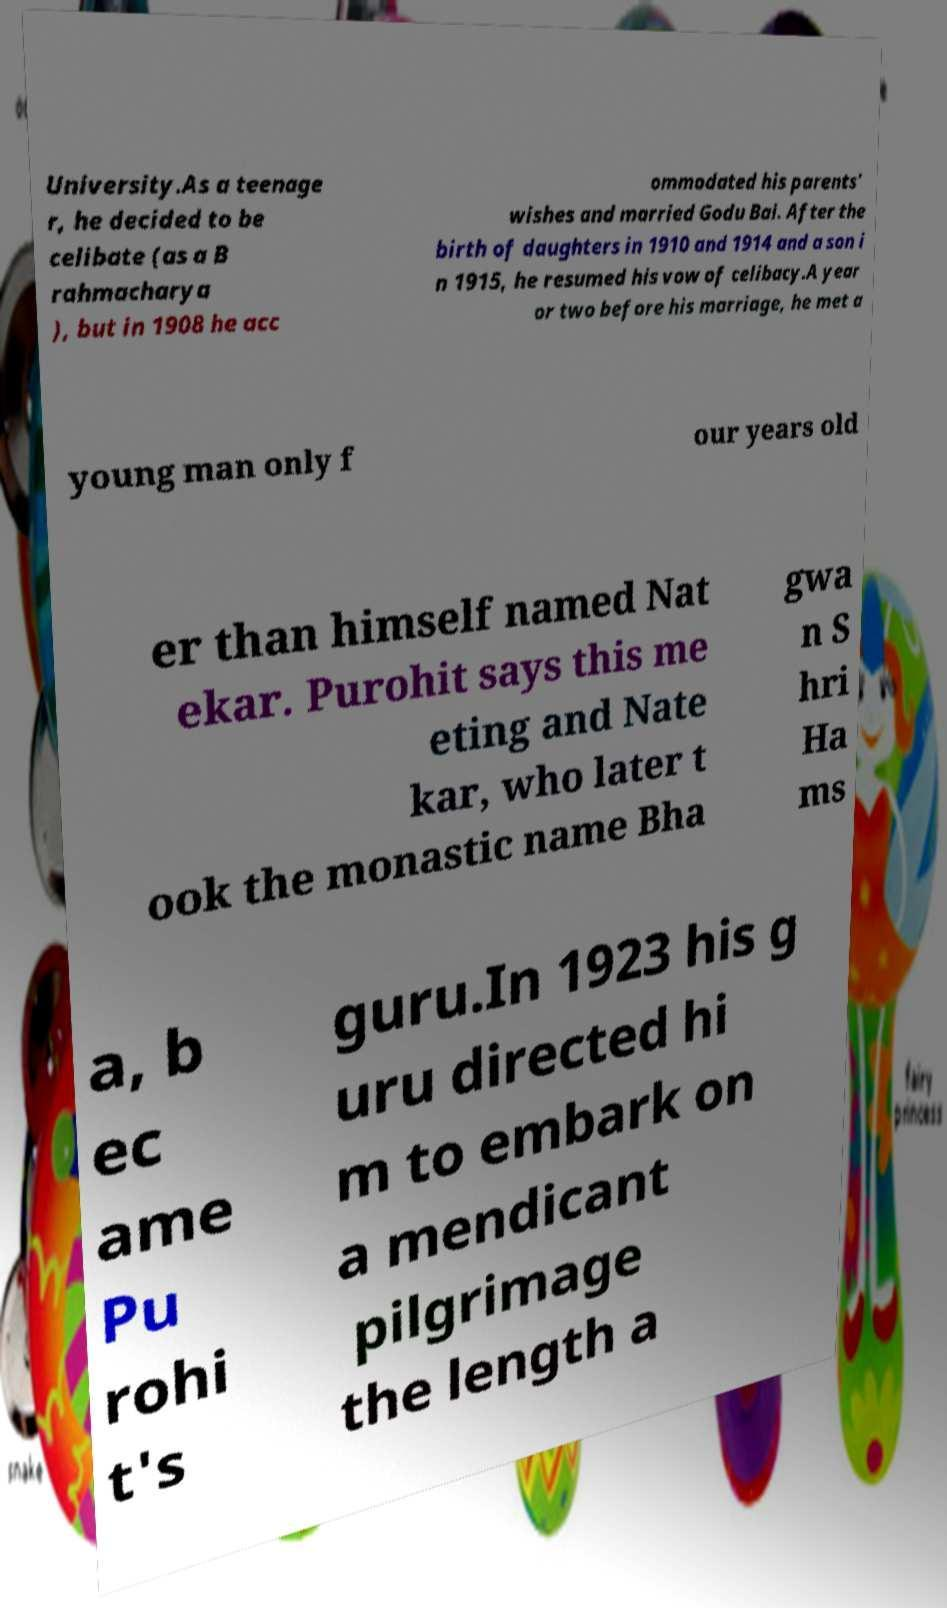There's text embedded in this image that I need extracted. Can you transcribe it verbatim? University.As a teenage r, he decided to be celibate (as a B rahmacharya ), but in 1908 he acc ommodated his parents' wishes and married Godu Bai. After the birth of daughters in 1910 and 1914 and a son i n 1915, he resumed his vow of celibacy.A year or two before his marriage, he met a young man only f our years old er than himself named Nat ekar. Purohit says this me eting and Nate kar, who later t ook the monastic name Bha gwa n S hri Ha ms a, b ec ame Pu rohi t's guru.In 1923 his g uru directed hi m to embark on a mendicant pilgrimage the length a 